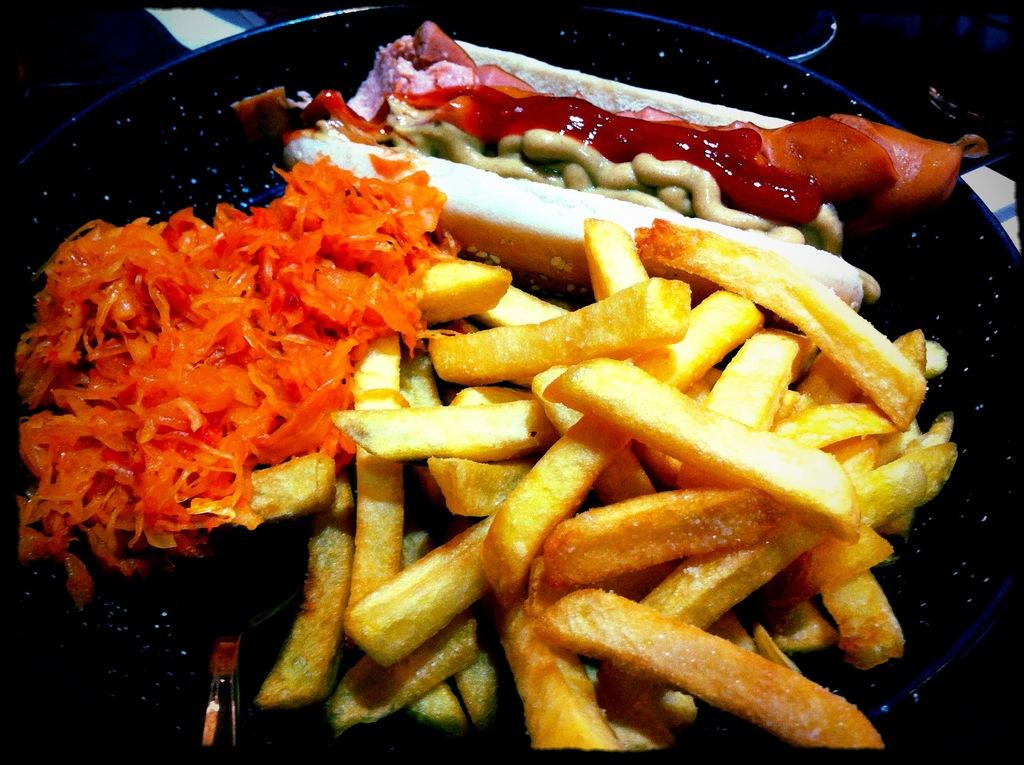What is on the plate in the image? There are food items on a plate in the image. What utensil is present on the plate? There is a spoon on the plate in the image. What type of scarf is being used to cook the food in the image? There is no scarf present in the image, nor is there any cooking activity depicted. 